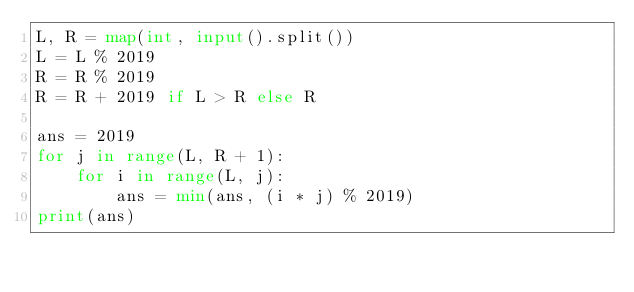Convert code to text. <code><loc_0><loc_0><loc_500><loc_500><_Python_>L, R = map(int, input().split())
L = L % 2019
R = R % 2019
R = R + 2019 if L > R else R

ans = 2019
for j in range(L, R + 1):
    for i in range(L, j):
        ans = min(ans, (i * j) % 2019)
print(ans)
</code> 